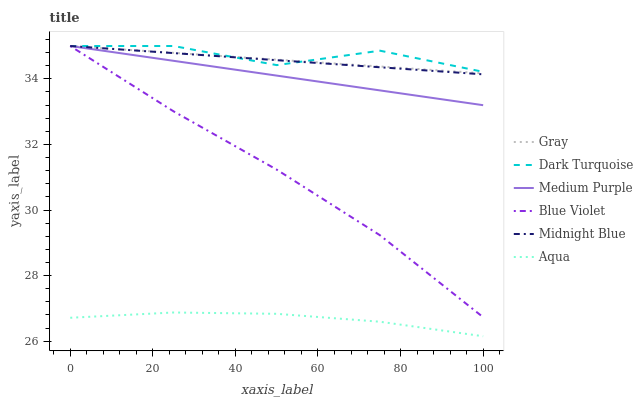Does Aqua have the minimum area under the curve?
Answer yes or no. Yes. Does Dark Turquoise have the maximum area under the curve?
Answer yes or no. Yes. Does Midnight Blue have the minimum area under the curve?
Answer yes or no. No. Does Midnight Blue have the maximum area under the curve?
Answer yes or no. No. Is Gray the smoothest?
Answer yes or no. Yes. Is Dark Turquoise the roughest?
Answer yes or no. Yes. Is Midnight Blue the smoothest?
Answer yes or no. No. Is Midnight Blue the roughest?
Answer yes or no. No. Does Aqua have the lowest value?
Answer yes or no. Yes. Does Midnight Blue have the lowest value?
Answer yes or no. No. Does Blue Violet have the highest value?
Answer yes or no. Yes. Does Aqua have the highest value?
Answer yes or no. No. Is Aqua less than Gray?
Answer yes or no. Yes. Is Gray greater than Aqua?
Answer yes or no. Yes. Does Midnight Blue intersect Dark Turquoise?
Answer yes or no. Yes. Is Midnight Blue less than Dark Turquoise?
Answer yes or no. No. Is Midnight Blue greater than Dark Turquoise?
Answer yes or no. No. Does Aqua intersect Gray?
Answer yes or no. No. 